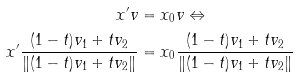<formula> <loc_0><loc_0><loc_500><loc_500>x ^ { \prime } v & = x _ { 0 } v \Leftrightarrow \\ x ^ { \prime } \frac { ( 1 - t ) v _ { 1 } + t v _ { 2 } } { \| ( 1 - t ) v _ { 1 } + t v _ { 2 } \| } & = x _ { 0 } \frac { ( 1 - t ) v _ { 1 } + t v _ { 2 } } { \| ( 1 - t ) v _ { 1 } + t v _ { 2 } \| }</formula> 